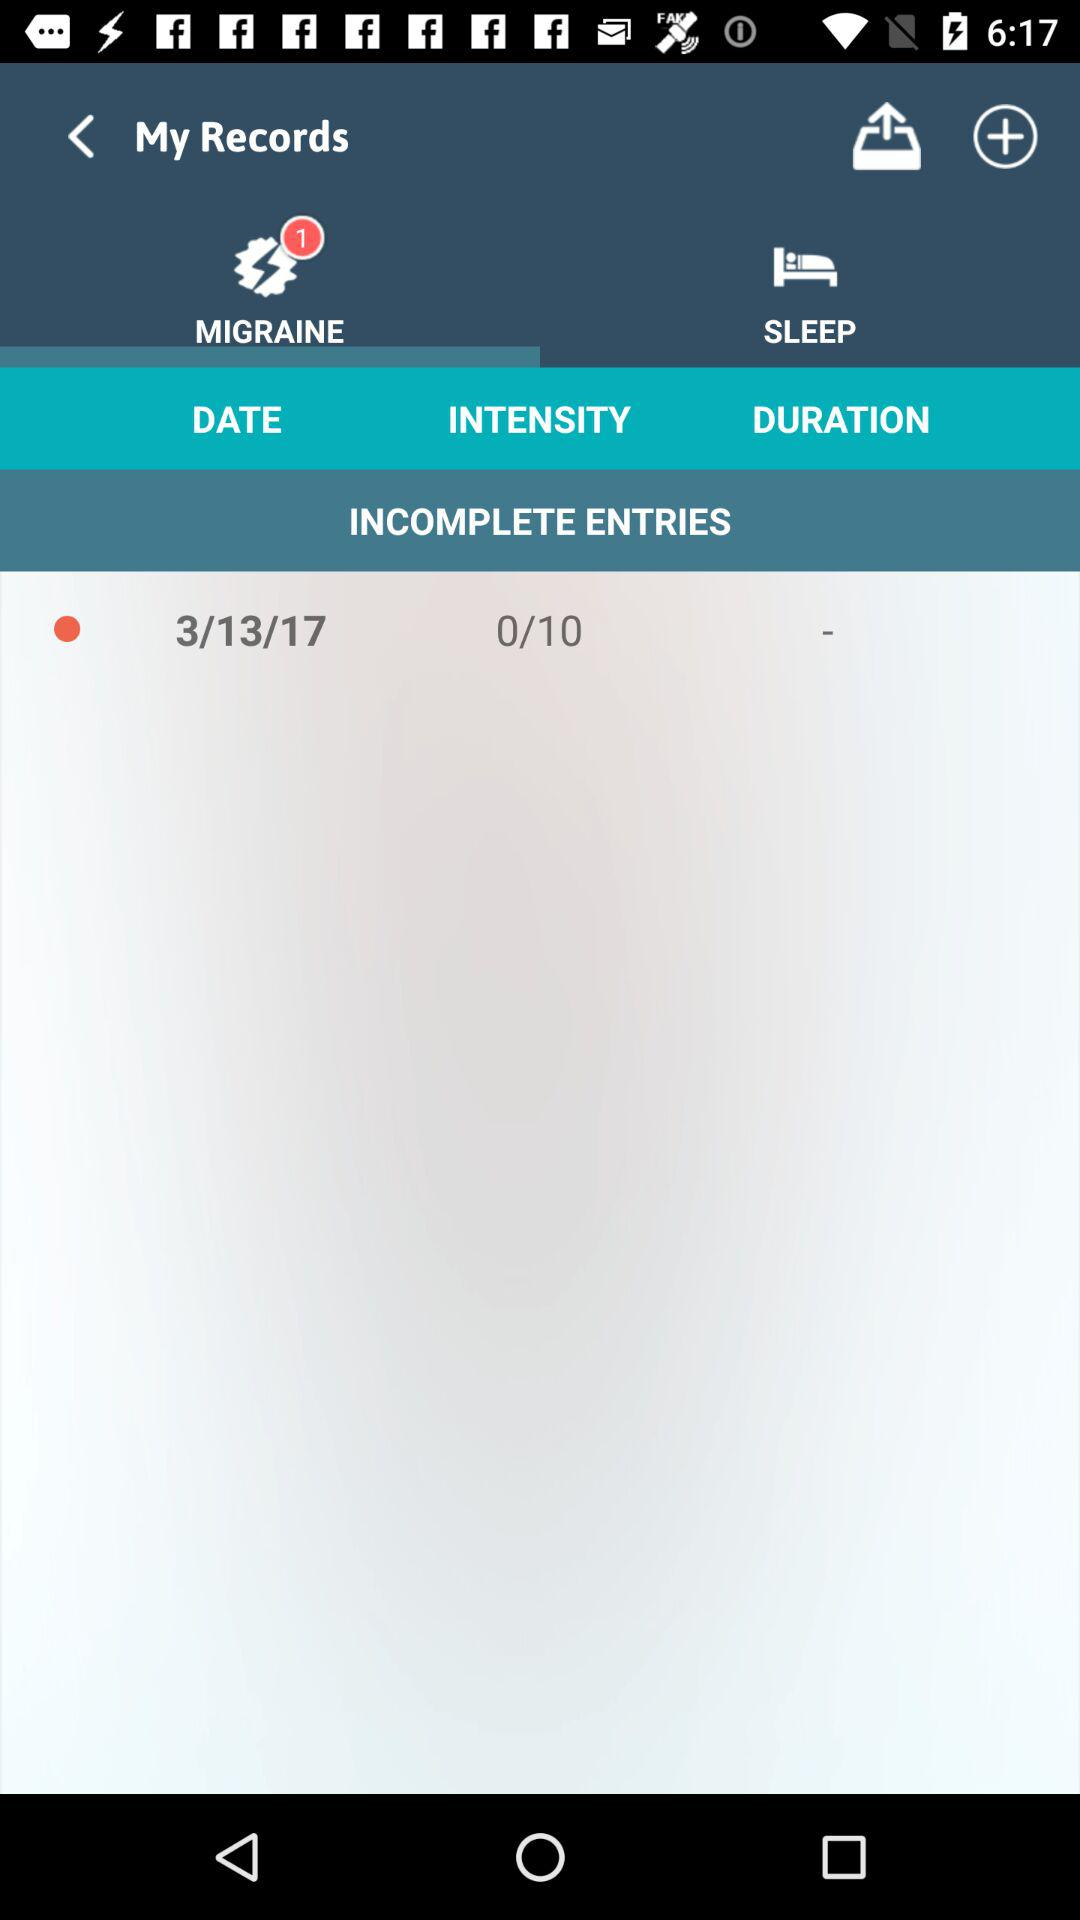What is the count of migraine? The count of migraine is 1. 